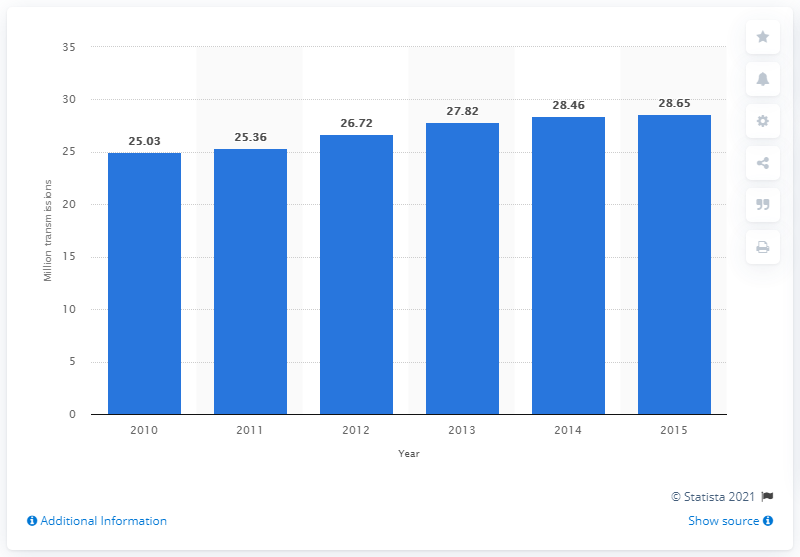List a handful of essential elements in this visual. By 2015, it is predicted that there will be 28.65 million automobiles with automatic transmissions. In 2010, it is estimated that 25.03 million cars and light vehicles in the United States were equipped with automatic transmissions. 